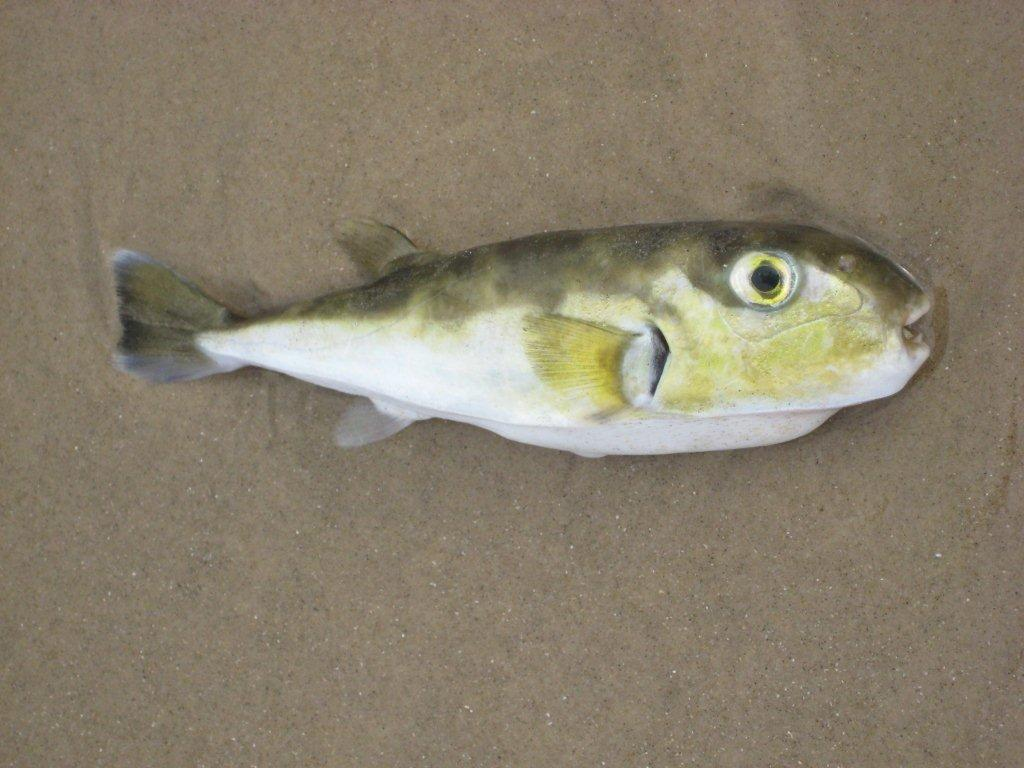What type of animal is in the image? There is a colorful fish in the image. Can you describe the appearance of the fish? The fish has a colorful appearance. What is the position of the farm in the image? There is no farm present in the image; it features a colorful fish. How does the quiet environment affect the fish in the image? The image does not provide information about the environment's quietness, and the fish's behavior cannot be determined based on the provided facts. 